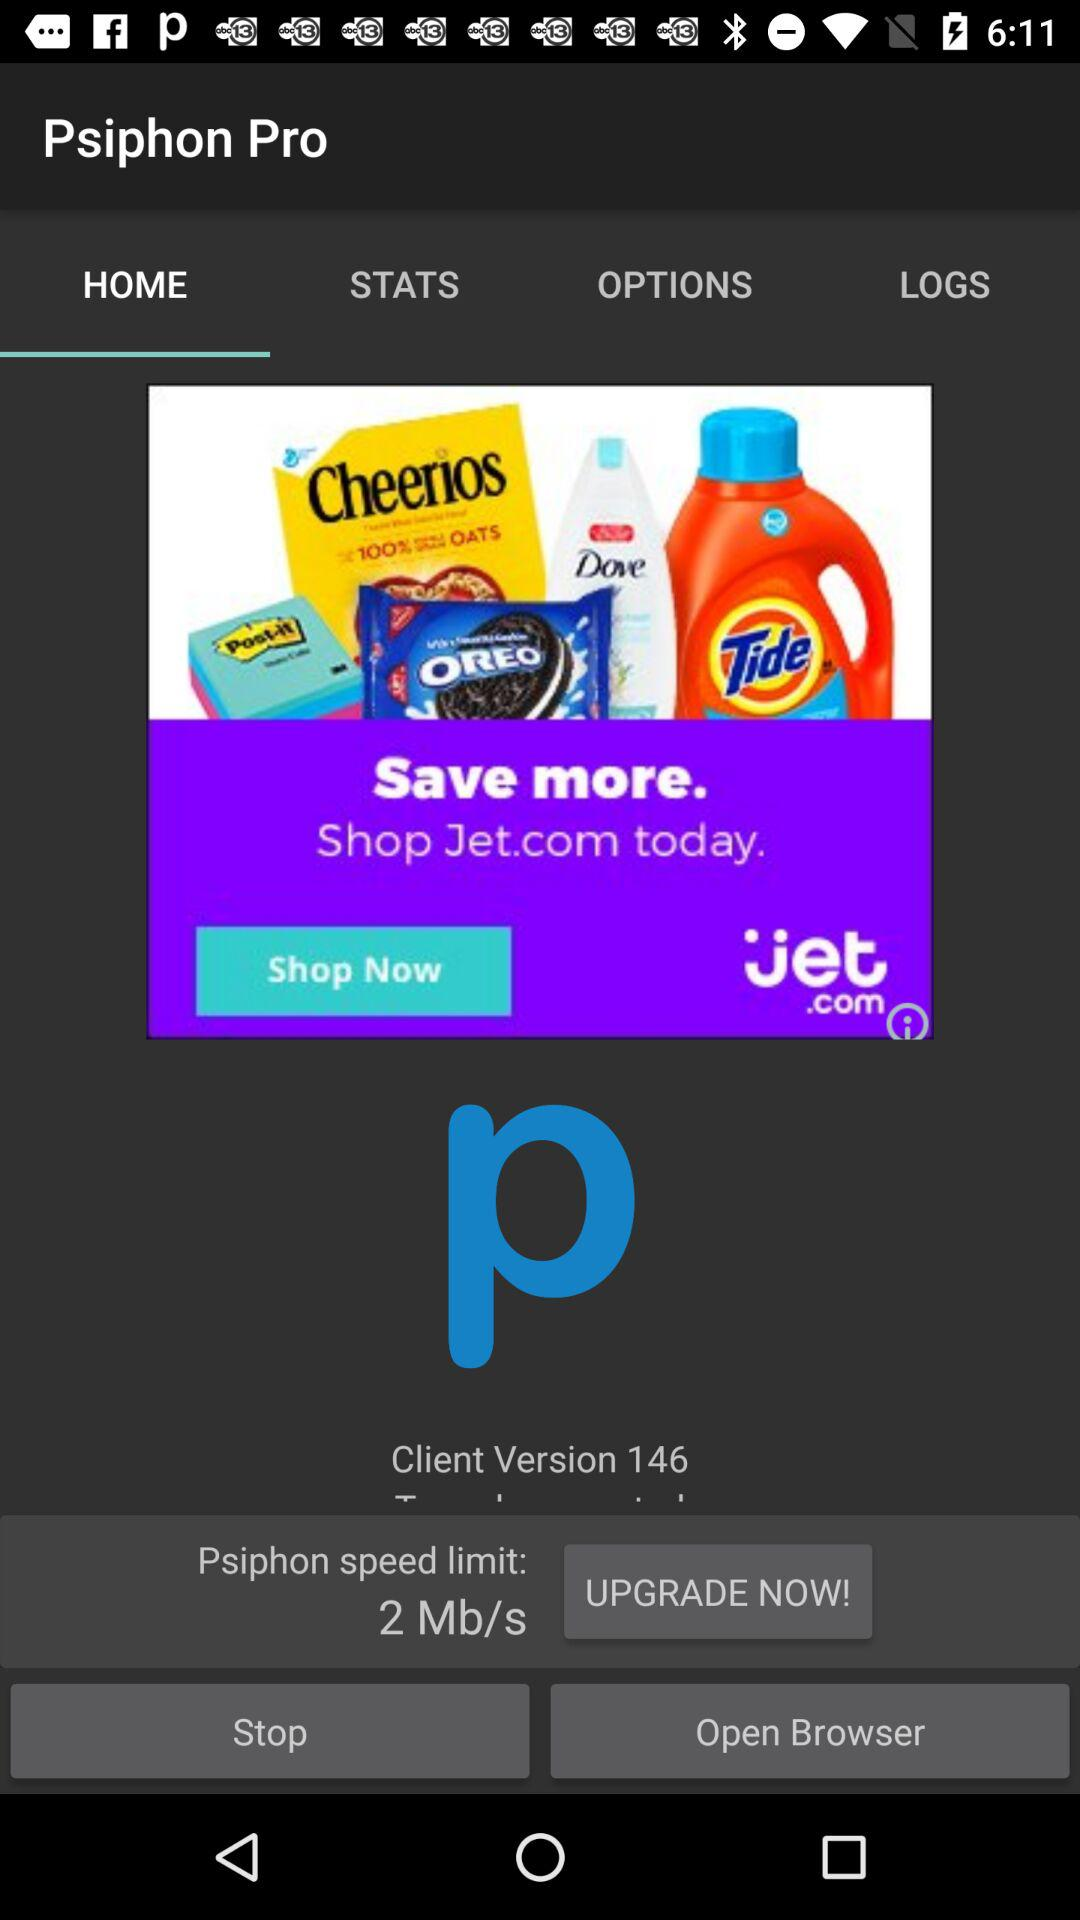What is the Psiphon speed limit? The Psiphon speed limit is 2 Mb/s. 